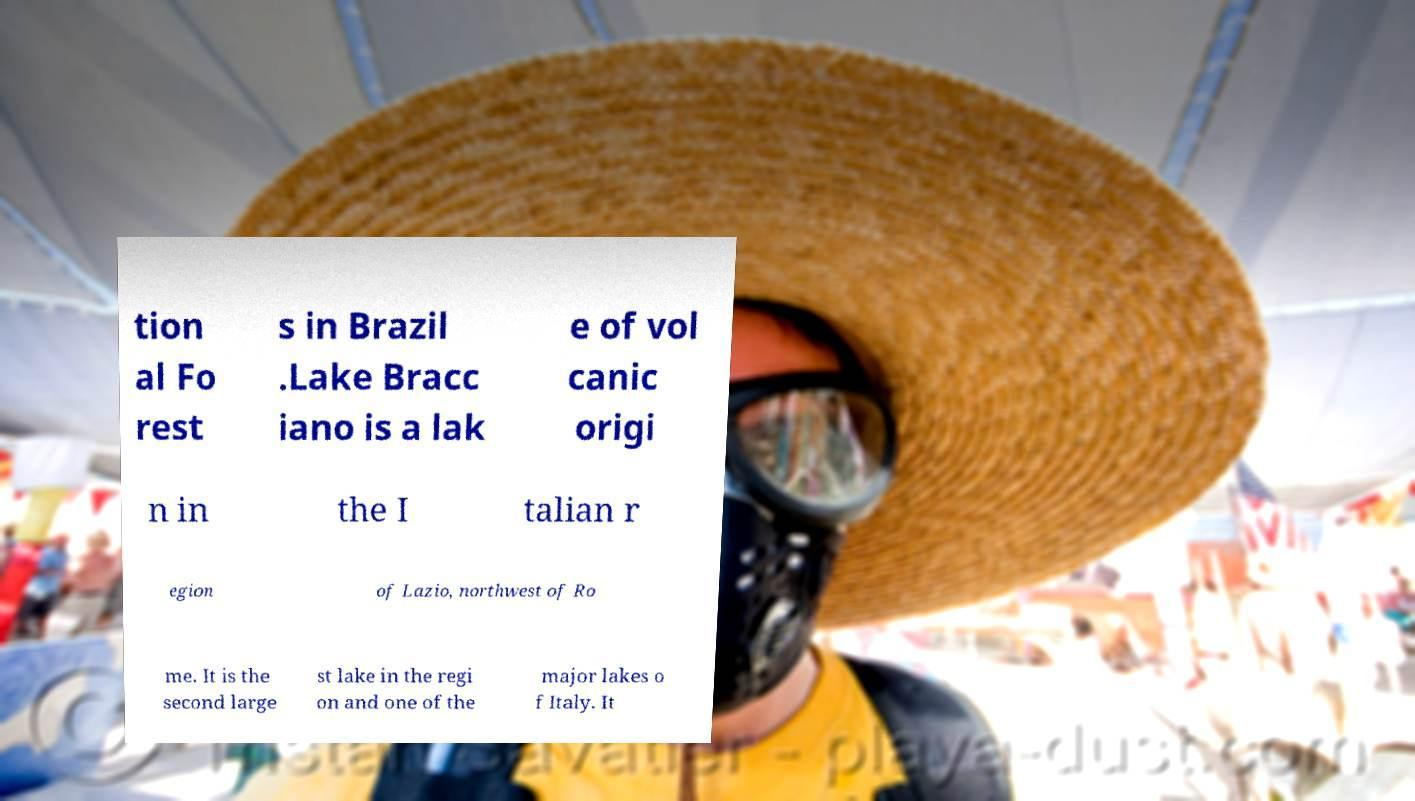What messages or text are displayed in this image? I need them in a readable, typed format. tion al Fo rest s in Brazil .Lake Bracc iano is a lak e of vol canic origi n in the I talian r egion of Lazio, northwest of Ro me. It is the second large st lake in the regi on and one of the major lakes o f Italy. It 